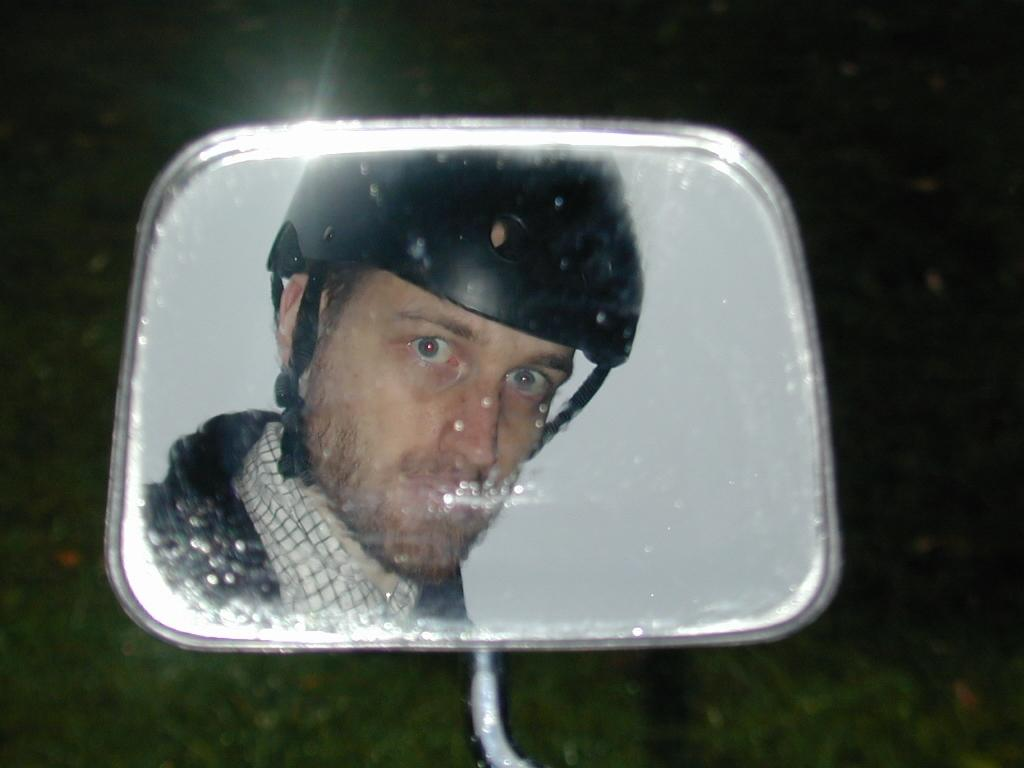What object is present in the image that allows for reflection? There is a mirror in the image. What can be seen in the mirror? A person wearing a helmet is visible in the mirror. How would you describe the overall clarity of the image? The background of the image is blurry. What type of vase is present on the person's hand in the image? There is no vase or hand present in the image; it only features a mirror and a person wearing a helmet. 